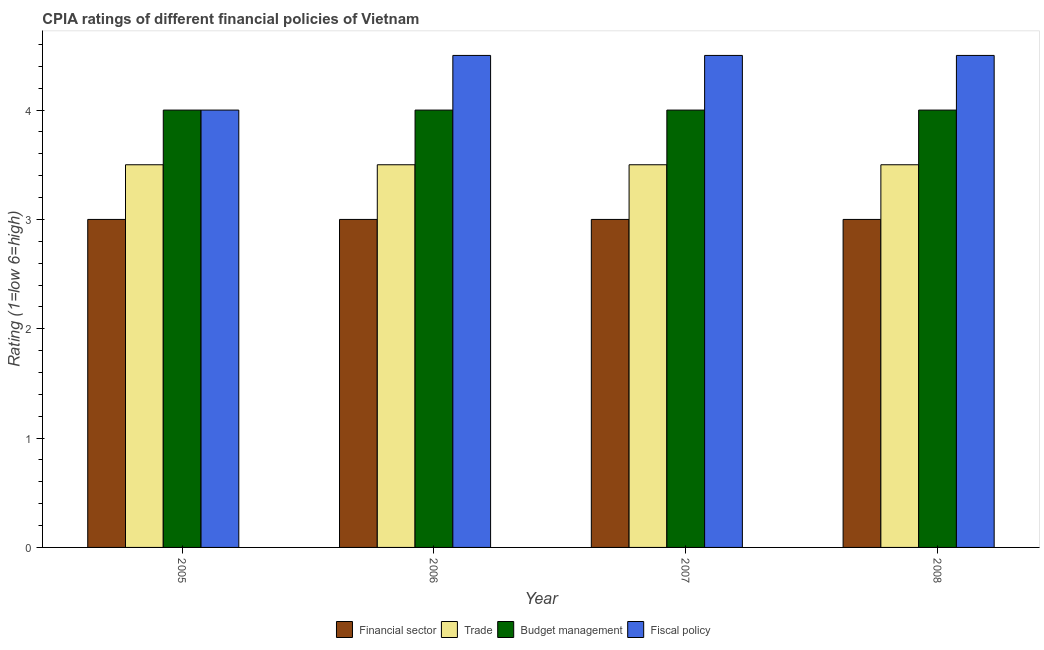Are the number of bars per tick equal to the number of legend labels?
Provide a succinct answer. Yes. How many bars are there on the 1st tick from the left?
Give a very brief answer. 4. How many bars are there on the 3rd tick from the right?
Your answer should be very brief. 4. What is the label of the 4th group of bars from the left?
Your response must be concise. 2008. In how many cases, is the number of bars for a given year not equal to the number of legend labels?
Make the answer very short. 0. Across all years, what is the minimum cpia rating of trade?
Your answer should be compact. 3.5. In which year was the cpia rating of financial sector maximum?
Your answer should be compact. 2005. What is the total cpia rating of financial sector in the graph?
Give a very brief answer. 12. What is the difference between the cpia rating of fiscal policy in 2005 and that in 2006?
Your answer should be compact. -0.5. What is the average cpia rating of trade per year?
Your answer should be compact. 3.5. In the year 2006, what is the difference between the cpia rating of trade and cpia rating of fiscal policy?
Your answer should be compact. 0. In how many years, is the cpia rating of fiscal policy greater than 2.8?
Offer a terse response. 4. What is the ratio of the cpia rating of trade in 2006 to that in 2008?
Give a very brief answer. 1. Is the difference between the cpia rating of fiscal policy in 2005 and 2007 greater than the difference between the cpia rating of budget management in 2005 and 2007?
Make the answer very short. No. What is the difference between the highest and the second highest cpia rating of budget management?
Make the answer very short. 0. What is the difference between the highest and the lowest cpia rating of fiscal policy?
Offer a terse response. 0.5. In how many years, is the cpia rating of fiscal policy greater than the average cpia rating of fiscal policy taken over all years?
Your answer should be compact. 3. Is the sum of the cpia rating of trade in 2006 and 2007 greater than the maximum cpia rating of budget management across all years?
Keep it short and to the point. Yes. Is it the case that in every year, the sum of the cpia rating of trade and cpia rating of fiscal policy is greater than the sum of cpia rating of budget management and cpia rating of financial sector?
Provide a succinct answer. No. What does the 2nd bar from the left in 2008 represents?
Ensure brevity in your answer.  Trade. What does the 1st bar from the right in 2006 represents?
Make the answer very short. Fiscal policy. Is it the case that in every year, the sum of the cpia rating of financial sector and cpia rating of trade is greater than the cpia rating of budget management?
Offer a very short reply. Yes. How many bars are there?
Provide a succinct answer. 16. Are the values on the major ticks of Y-axis written in scientific E-notation?
Your response must be concise. No. Does the graph contain any zero values?
Make the answer very short. No. Where does the legend appear in the graph?
Give a very brief answer. Bottom center. What is the title of the graph?
Give a very brief answer. CPIA ratings of different financial policies of Vietnam. What is the label or title of the X-axis?
Your answer should be very brief. Year. What is the label or title of the Y-axis?
Make the answer very short. Rating (1=low 6=high). What is the Rating (1=low 6=high) in Budget management in 2005?
Provide a succinct answer. 4. What is the Rating (1=low 6=high) in Trade in 2006?
Your answer should be compact. 3.5. What is the Rating (1=low 6=high) of Trade in 2007?
Ensure brevity in your answer.  3.5. What is the Rating (1=low 6=high) in Fiscal policy in 2007?
Ensure brevity in your answer.  4.5. What is the Rating (1=low 6=high) in Financial sector in 2008?
Your answer should be compact. 3. What is the Rating (1=low 6=high) in Fiscal policy in 2008?
Keep it short and to the point. 4.5. Across all years, what is the maximum Rating (1=low 6=high) of Trade?
Your answer should be compact. 3.5. Across all years, what is the minimum Rating (1=low 6=high) in Budget management?
Your answer should be very brief. 4. Across all years, what is the minimum Rating (1=low 6=high) in Fiscal policy?
Provide a succinct answer. 4. What is the total Rating (1=low 6=high) in Budget management in the graph?
Your response must be concise. 16. What is the difference between the Rating (1=low 6=high) of Trade in 2005 and that in 2006?
Make the answer very short. 0. What is the difference between the Rating (1=low 6=high) of Fiscal policy in 2005 and that in 2006?
Your answer should be very brief. -0.5. What is the difference between the Rating (1=low 6=high) of Financial sector in 2005 and that in 2007?
Offer a very short reply. 0. What is the difference between the Rating (1=low 6=high) of Trade in 2005 and that in 2007?
Your answer should be compact. 0. What is the difference between the Rating (1=low 6=high) in Trade in 2005 and that in 2008?
Your answer should be very brief. 0. What is the difference between the Rating (1=low 6=high) in Budget management in 2005 and that in 2008?
Your answer should be compact. 0. What is the difference between the Rating (1=low 6=high) of Financial sector in 2006 and that in 2008?
Give a very brief answer. 0. What is the difference between the Rating (1=low 6=high) in Trade in 2006 and that in 2008?
Offer a terse response. 0. What is the difference between the Rating (1=low 6=high) in Budget management in 2006 and that in 2008?
Your response must be concise. 0. What is the difference between the Rating (1=low 6=high) of Financial sector in 2007 and that in 2008?
Ensure brevity in your answer.  0. What is the difference between the Rating (1=low 6=high) in Budget management in 2007 and that in 2008?
Your response must be concise. 0. What is the difference between the Rating (1=low 6=high) of Fiscal policy in 2007 and that in 2008?
Give a very brief answer. 0. What is the difference between the Rating (1=low 6=high) in Financial sector in 2005 and the Rating (1=low 6=high) in Trade in 2006?
Ensure brevity in your answer.  -0.5. What is the difference between the Rating (1=low 6=high) of Financial sector in 2005 and the Rating (1=low 6=high) of Budget management in 2006?
Your answer should be compact. -1. What is the difference between the Rating (1=low 6=high) of Financial sector in 2005 and the Rating (1=low 6=high) of Fiscal policy in 2006?
Offer a terse response. -1.5. What is the difference between the Rating (1=low 6=high) of Financial sector in 2005 and the Rating (1=low 6=high) of Fiscal policy in 2007?
Keep it short and to the point. -1.5. What is the difference between the Rating (1=low 6=high) in Budget management in 2005 and the Rating (1=low 6=high) in Fiscal policy in 2007?
Keep it short and to the point. -0.5. What is the difference between the Rating (1=low 6=high) in Financial sector in 2005 and the Rating (1=low 6=high) in Budget management in 2008?
Provide a succinct answer. -1. What is the difference between the Rating (1=low 6=high) in Trade in 2005 and the Rating (1=low 6=high) in Fiscal policy in 2008?
Your answer should be compact. -1. What is the difference between the Rating (1=low 6=high) in Budget management in 2005 and the Rating (1=low 6=high) in Fiscal policy in 2008?
Give a very brief answer. -0.5. What is the difference between the Rating (1=low 6=high) in Financial sector in 2006 and the Rating (1=low 6=high) in Budget management in 2007?
Provide a succinct answer. -1. What is the difference between the Rating (1=low 6=high) of Financial sector in 2006 and the Rating (1=low 6=high) of Fiscal policy in 2007?
Provide a short and direct response. -1.5. What is the difference between the Rating (1=low 6=high) in Trade in 2006 and the Rating (1=low 6=high) in Budget management in 2007?
Make the answer very short. -0.5. What is the difference between the Rating (1=low 6=high) in Financial sector in 2006 and the Rating (1=low 6=high) in Trade in 2008?
Offer a terse response. -0.5. What is the difference between the Rating (1=low 6=high) of Financial sector in 2006 and the Rating (1=low 6=high) of Budget management in 2008?
Offer a terse response. -1. What is the difference between the Rating (1=low 6=high) in Financial sector in 2006 and the Rating (1=low 6=high) in Fiscal policy in 2008?
Provide a succinct answer. -1.5. What is the difference between the Rating (1=low 6=high) of Trade in 2006 and the Rating (1=low 6=high) of Fiscal policy in 2008?
Provide a succinct answer. -1. What is the difference between the Rating (1=low 6=high) of Budget management in 2006 and the Rating (1=low 6=high) of Fiscal policy in 2008?
Ensure brevity in your answer.  -0.5. What is the difference between the Rating (1=low 6=high) in Financial sector in 2007 and the Rating (1=low 6=high) in Budget management in 2008?
Offer a terse response. -1. What is the difference between the Rating (1=low 6=high) of Trade in 2007 and the Rating (1=low 6=high) of Budget management in 2008?
Offer a terse response. -0.5. What is the difference between the Rating (1=low 6=high) of Budget management in 2007 and the Rating (1=low 6=high) of Fiscal policy in 2008?
Make the answer very short. -0.5. What is the average Rating (1=low 6=high) of Budget management per year?
Offer a very short reply. 4. What is the average Rating (1=low 6=high) of Fiscal policy per year?
Your answer should be very brief. 4.38. In the year 2005, what is the difference between the Rating (1=low 6=high) in Financial sector and Rating (1=low 6=high) in Trade?
Keep it short and to the point. -0.5. In the year 2005, what is the difference between the Rating (1=low 6=high) of Financial sector and Rating (1=low 6=high) of Budget management?
Your answer should be very brief. -1. In the year 2005, what is the difference between the Rating (1=low 6=high) of Financial sector and Rating (1=low 6=high) of Fiscal policy?
Provide a short and direct response. -1. In the year 2005, what is the difference between the Rating (1=low 6=high) in Trade and Rating (1=low 6=high) in Budget management?
Provide a succinct answer. -0.5. In the year 2005, what is the difference between the Rating (1=low 6=high) in Budget management and Rating (1=low 6=high) in Fiscal policy?
Give a very brief answer. 0. In the year 2006, what is the difference between the Rating (1=low 6=high) of Financial sector and Rating (1=low 6=high) of Trade?
Keep it short and to the point. -0.5. In the year 2006, what is the difference between the Rating (1=low 6=high) of Financial sector and Rating (1=low 6=high) of Budget management?
Ensure brevity in your answer.  -1. In the year 2006, what is the difference between the Rating (1=low 6=high) in Budget management and Rating (1=low 6=high) in Fiscal policy?
Keep it short and to the point. -0.5. In the year 2007, what is the difference between the Rating (1=low 6=high) in Financial sector and Rating (1=low 6=high) in Fiscal policy?
Make the answer very short. -1.5. In the year 2007, what is the difference between the Rating (1=low 6=high) in Trade and Rating (1=low 6=high) in Budget management?
Provide a succinct answer. -0.5. What is the ratio of the Rating (1=low 6=high) of Financial sector in 2005 to that in 2006?
Ensure brevity in your answer.  1. What is the ratio of the Rating (1=low 6=high) of Budget management in 2005 to that in 2006?
Provide a short and direct response. 1. What is the ratio of the Rating (1=low 6=high) in Fiscal policy in 2005 to that in 2006?
Provide a short and direct response. 0.89. What is the ratio of the Rating (1=low 6=high) of Financial sector in 2005 to that in 2007?
Provide a short and direct response. 1. What is the ratio of the Rating (1=low 6=high) in Budget management in 2005 to that in 2007?
Your response must be concise. 1. What is the ratio of the Rating (1=low 6=high) in Fiscal policy in 2005 to that in 2007?
Keep it short and to the point. 0.89. What is the ratio of the Rating (1=low 6=high) of Trade in 2005 to that in 2008?
Make the answer very short. 1. What is the ratio of the Rating (1=low 6=high) in Budget management in 2005 to that in 2008?
Make the answer very short. 1. What is the ratio of the Rating (1=low 6=high) of Fiscal policy in 2005 to that in 2008?
Your answer should be very brief. 0.89. What is the ratio of the Rating (1=low 6=high) of Financial sector in 2006 to that in 2007?
Give a very brief answer. 1. What is the ratio of the Rating (1=low 6=high) of Budget management in 2006 to that in 2007?
Offer a terse response. 1. What is the ratio of the Rating (1=low 6=high) in Fiscal policy in 2006 to that in 2007?
Keep it short and to the point. 1. What is the ratio of the Rating (1=low 6=high) of Financial sector in 2006 to that in 2008?
Your response must be concise. 1. What is the ratio of the Rating (1=low 6=high) in Budget management in 2006 to that in 2008?
Make the answer very short. 1. What is the ratio of the Rating (1=low 6=high) of Financial sector in 2007 to that in 2008?
Your answer should be compact. 1. What is the ratio of the Rating (1=low 6=high) of Trade in 2007 to that in 2008?
Keep it short and to the point. 1. What is the difference between the highest and the second highest Rating (1=low 6=high) in Trade?
Keep it short and to the point. 0. What is the difference between the highest and the second highest Rating (1=low 6=high) in Fiscal policy?
Ensure brevity in your answer.  0. What is the difference between the highest and the lowest Rating (1=low 6=high) of Financial sector?
Your answer should be compact. 0. What is the difference between the highest and the lowest Rating (1=low 6=high) in Trade?
Make the answer very short. 0. What is the difference between the highest and the lowest Rating (1=low 6=high) in Fiscal policy?
Keep it short and to the point. 0.5. 